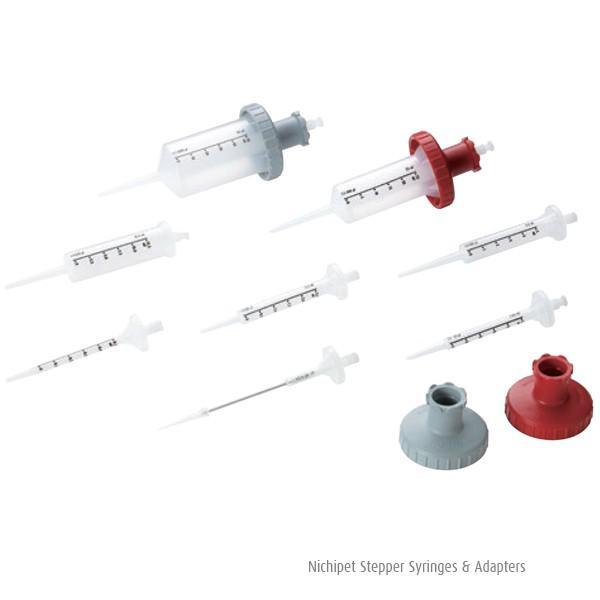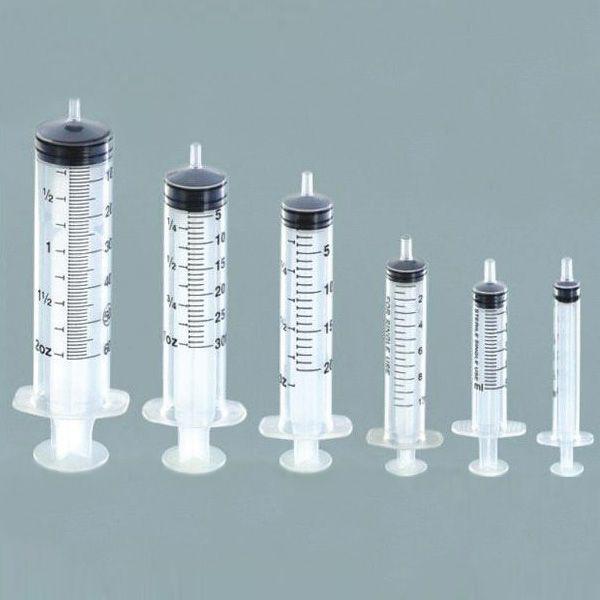The first image is the image on the left, the second image is the image on the right. Analyze the images presented: Is the assertion "There is a single syringe in one of the images and at least twice as many in the other." valid? Answer yes or no. No. The first image is the image on the left, the second image is the image on the right. For the images shown, is this caption "There are more needles in the right image." true? Answer yes or no. No. 